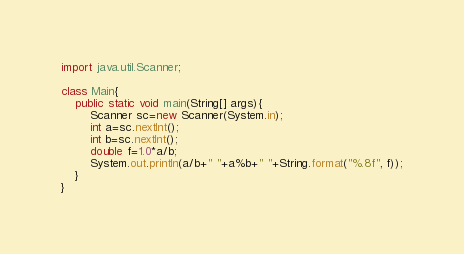Convert code to text. <code><loc_0><loc_0><loc_500><loc_500><_Java_>import java.util.Scanner;

class Main{
    public static void main(String[] args){
        Scanner sc=new Scanner(System.in);
        int a=sc.nextInt();
        int b=sc.nextInt();
        double f=1.0*a/b;
        System.out.println(a/b+" "+a%b+" "+String.format("%.8f", f));
    }
}

</code> 